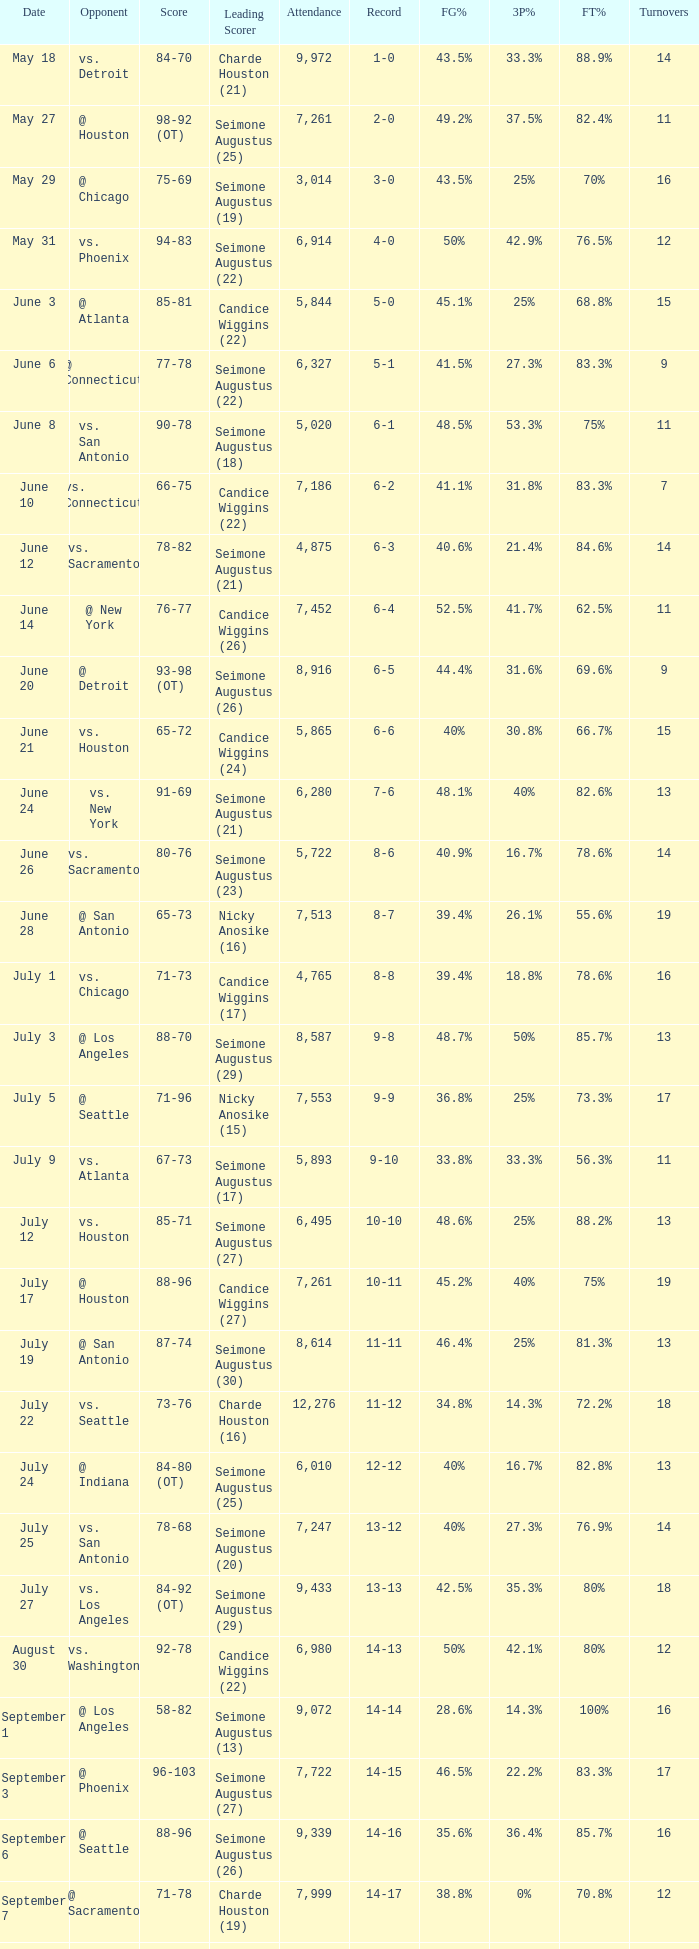Which Leading Scorer has an Opponent of @ seattle, and a Record of 14-16? Seimone Augustus (26). 